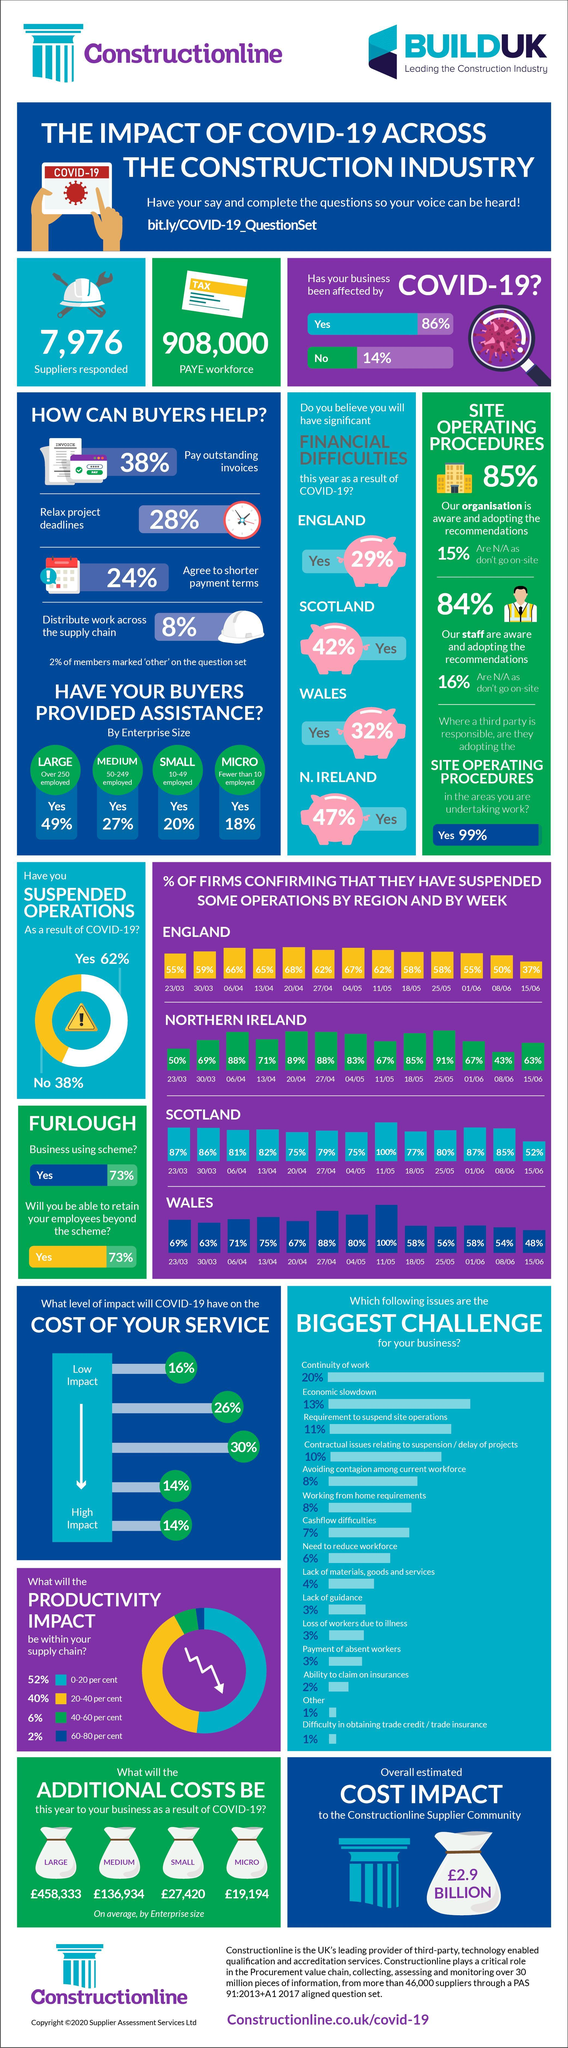What percentage of firms confirmed that they have suspended some operations in Northern Ireland on 20/04 due to the impact of COVID-19?
Answer the question with a short phrase. 89% What percentage of firms in the UK believe that cashflow difficulties is the biggest challenge for their business due to the impact of COVID-19? 7% What is the average additional costs (in pounds) for Medium size enterprises in the UK as a result of COVID-19? 136,934 What percentage of firms in the UK think that economic slowdown is the biggest challenge for their business due to the impact of COVID-19? 13% What is the average additional costs (in pounds) for small size enterprises in the UK as a result of COVID-19? 27,420 What percentage of firms confirmed that they have suspended some operations in the Wales on 11/05 due to the impact of COVID-19? 100% What percentage of firms confirmed that they have suspended some operations in the Scotland on 13/04 due to the impact of COVID-19? 82% 